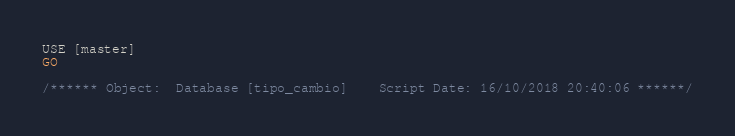Convert code to text. <code><loc_0><loc_0><loc_500><loc_500><_SQL_>USE [master]
GO

/****** Object:  Database [tipo_cambio]    Script Date: 16/10/2018 20:40:06 ******/</code> 